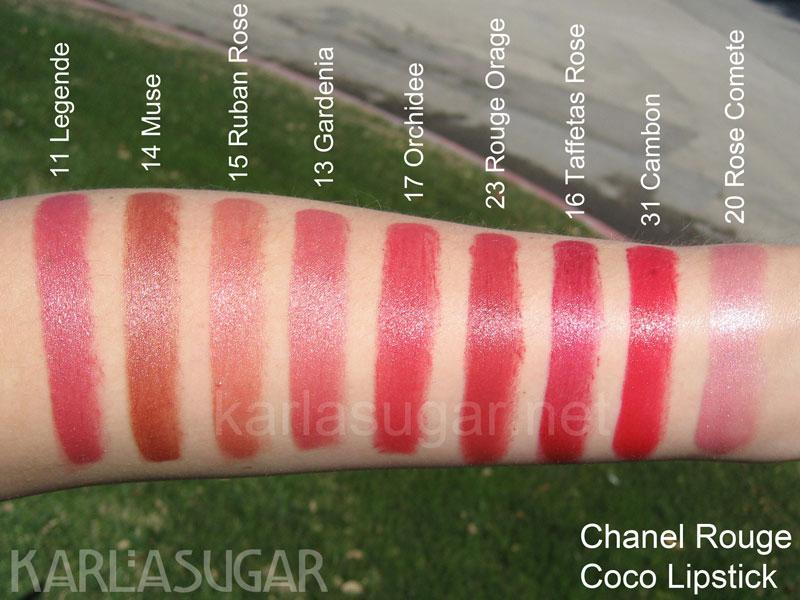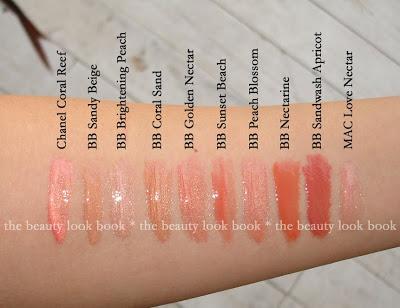The first image is the image on the left, the second image is the image on the right. For the images shown, is this caption "The person in the left image has lighter skin than the person in the right image." true? Answer yes or no. Yes. The first image is the image on the left, the second image is the image on the right. Evaluate the accuracy of this statement regarding the images: "Each image shows lipstick marks on skin displayed in a horizontal row.". Is it true? Answer yes or no. Yes. 